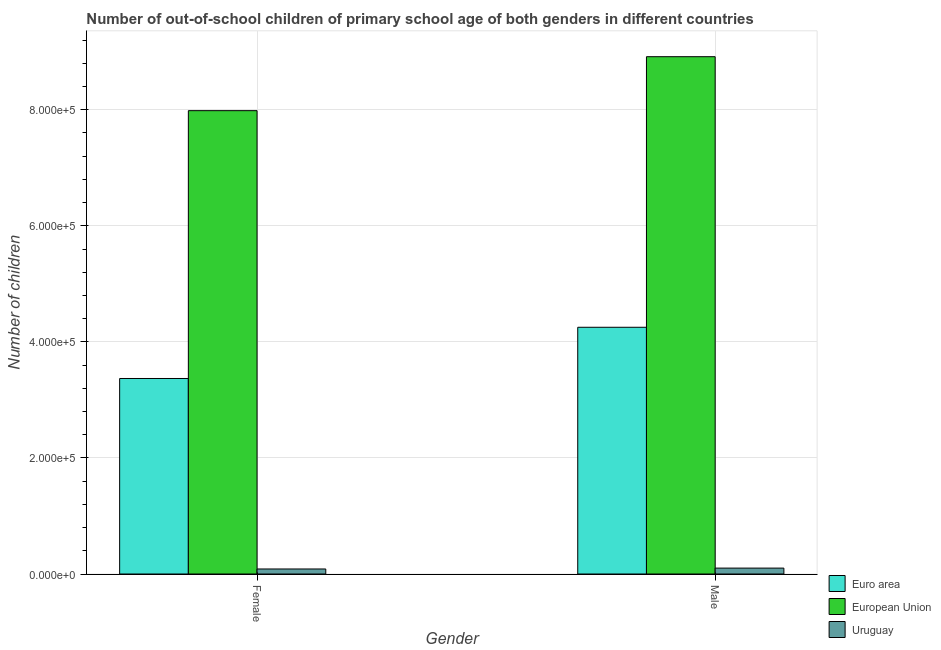How many different coloured bars are there?
Offer a very short reply. 3. Are the number of bars on each tick of the X-axis equal?
Keep it short and to the point. Yes. How many bars are there on the 1st tick from the right?
Offer a very short reply. 3. What is the label of the 1st group of bars from the left?
Offer a very short reply. Female. What is the number of male out-of-school students in Euro area?
Make the answer very short. 4.25e+05. Across all countries, what is the maximum number of female out-of-school students?
Make the answer very short. 7.98e+05. Across all countries, what is the minimum number of male out-of-school students?
Offer a very short reply. 1.02e+04. In which country was the number of male out-of-school students maximum?
Keep it short and to the point. European Union. In which country was the number of female out-of-school students minimum?
Provide a short and direct response. Uruguay. What is the total number of male out-of-school students in the graph?
Your answer should be very brief. 1.33e+06. What is the difference between the number of female out-of-school students in Uruguay and that in Euro area?
Make the answer very short. -3.28e+05. What is the difference between the number of female out-of-school students in European Union and the number of male out-of-school students in Euro area?
Offer a very short reply. 3.73e+05. What is the average number of male out-of-school students per country?
Provide a succinct answer. 4.42e+05. What is the difference between the number of male out-of-school students and number of female out-of-school students in European Union?
Give a very brief answer. 9.30e+04. In how many countries, is the number of female out-of-school students greater than 360000 ?
Keep it short and to the point. 1. What is the ratio of the number of male out-of-school students in Uruguay to that in Euro area?
Your answer should be compact. 0.02. Is the number of male out-of-school students in Euro area less than that in European Union?
Keep it short and to the point. Yes. What does the 3rd bar from the left in Female represents?
Offer a terse response. Uruguay. What does the 1st bar from the right in Female represents?
Offer a very short reply. Uruguay. Are all the bars in the graph horizontal?
Offer a terse response. No. Does the graph contain any zero values?
Your response must be concise. No. Where does the legend appear in the graph?
Ensure brevity in your answer.  Bottom right. How are the legend labels stacked?
Your answer should be compact. Vertical. What is the title of the graph?
Offer a very short reply. Number of out-of-school children of primary school age of both genders in different countries. Does "Middle East & North Africa (developing only)" appear as one of the legend labels in the graph?
Ensure brevity in your answer.  No. What is the label or title of the X-axis?
Provide a short and direct response. Gender. What is the label or title of the Y-axis?
Make the answer very short. Number of children. What is the Number of children in Euro area in Female?
Offer a very short reply. 3.37e+05. What is the Number of children in European Union in Female?
Offer a terse response. 7.98e+05. What is the Number of children in Uruguay in Female?
Your answer should be very brief. 8652. What is the Number of children in Euro area in Male?
Your answer should be compact. 4.25e+05. What is the Number of children in European Union in Male?
Provide a succinct answer. 8.91e+05. What is the Number of children of Uruguay in Male?
Your answer should be compact. 1.02e+04. Across all Gender, what is the maximum Number of children of Euro area?
Your answer should be compact. 4.25e+05. Across all Gender, what is the maximum Number of children of European Union?
Your response must be concise. 8.91e+05. Across all Gender, what is the maximum Number of children of Uruguay?
Offer a terse response. 1.02e+04. Across all Gender, what is the minimum Number of children of Euro area?
Offer a very short reply. 3.37e+05. Across all Gender, what is the minimum Number of children of European Union?
Provide a succinct answer. 7.98e+05. Across all Gender, what is the minimum Number of children of Uruguay?
Give a very brief answer. 8652. What is the total Number of children of Euro area in the graph?
Your answer should be very brief. 7.62e+05. What is the total Number of children in European Union in the graph?
Your answer should be very brief. 1.69e+06. What is the total Number of children in Uruguay in the graph?
Your response must be concise. 1.88e+04. What is the difference between the Number of children in Euro area in Female and that in Male?
Make the answer very short. -8.83e+04. What is the difference between the Number of children of European Union in Female and that in Male?
Make the answer very short. -9.30e+04. What is the difference between the Number of children in Uruguay in Female and that in Male?
Your answer should be very brief. -1510. What is the difference between the Number of children in Euro area in Female and the Number of children in European Union in Male?
Your answer should be compact. -5.55e+05. What is the difference between the Number of children in Euro area in Female and the Number of children in Uruguay in Male?
Provide a short and direct response. 3.27e+05. What is the difference between the Number of children in European Union in Female and the Number of children in Uruguay in Male?
Ensure brevity in your answer.  7.88e+05. What is the average Number of children in Euro area per Gender?
Offer a terse response. 3.81e+05. What is the average Number of children of European Union per Gender?
Offer a very short reply. 8.45e+05. What is the average Number of children of Uruguay per Gender?
Your response must be concise. 9407. What is the difference between the Number of children of Euro area and Number of children of European Union in Female?
Your answer should be compact. -4.62e+05. What is the difference between the Number of children of Euro area and Number of children of Uruguay in Female?
Make the answer very short. 3.28e+05. What is the difference between the Number of children of European Union and Number of children of Uruguay in Female?
Offer a terse response. 7.90e+05. What is the difference between the Number of children in Euro area and Number of children in European Union in Male?
Make the answer very short. -4.66e+05. What is the difference between the Number of children in Euro area and Number of children in Uruguay in Male?
Offer a very short reply. 4.15e+05. What is the difference between the Number of children in European Union and Number of children in Uruguay in Male?
Keep it short and to the point. 8.81e+05. What is the ratio of the Number of children in Euro area in Female to that in Male?
Your answer should be very brief. 0.79. What is the ratio of the Number of children of European Union in Female to that in Male?
Provide a short and direct response. 0.9. What is the ratio of the Number of children of Uruguay in Female to that in Male?
Ensure brevity in your answer.  0.85. What is the difference between the highest and the second highest Number of children in Euro area?
Give a very brief answer. 8.83e+04. What is the difference between the highest and the second highest Number of children in European Union?
Give a very brief answer. 9.30e+04. What is the difference between the highest and the second highest Number of children of Uruguay?
Offer a very short reply. 1510. What is the difference between the highest and the lowest Number of children of Euro area?
Offer a terse response. 8.83e+04. What is the difference between the highest and the lowest Number of children of European Union?
Your response must be concise. 9.30e+04. What is the difference between the highest and the lowest Number of children in Uruguay?
Offer a very short reply. 1510. 